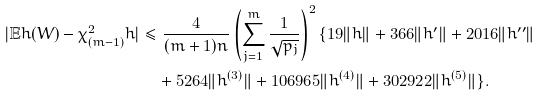<formula> <loc_0><loc_0><loc_500><loc_500>| \mathbb { E } h ( W ) - \chi ^ { 2 } _ { ( m - 1 ) } h | & \leq \frac { 4 } { ( m + 1 ) n } \left ( \sum _ { j = 1 } ^ { m } \frac { 1 } { \sqrt { p _ { j } } } \right ) ^ { 2 } \{ 1 9 \| h \| + 3 6 6 \| h ^ { \prime } \| + 2 0 1 6 \| h ^ { \prime \prime } \| \\ & \quad + 5 2 6 4 \| h ^ { ( 3 ) } \| + 1 0 6 9 6 5 \| h ^ { ( 4 ) } \| + 3 0 2 9 2 2 \| h ^ { ( 5 ) } \| \} .</formula> 